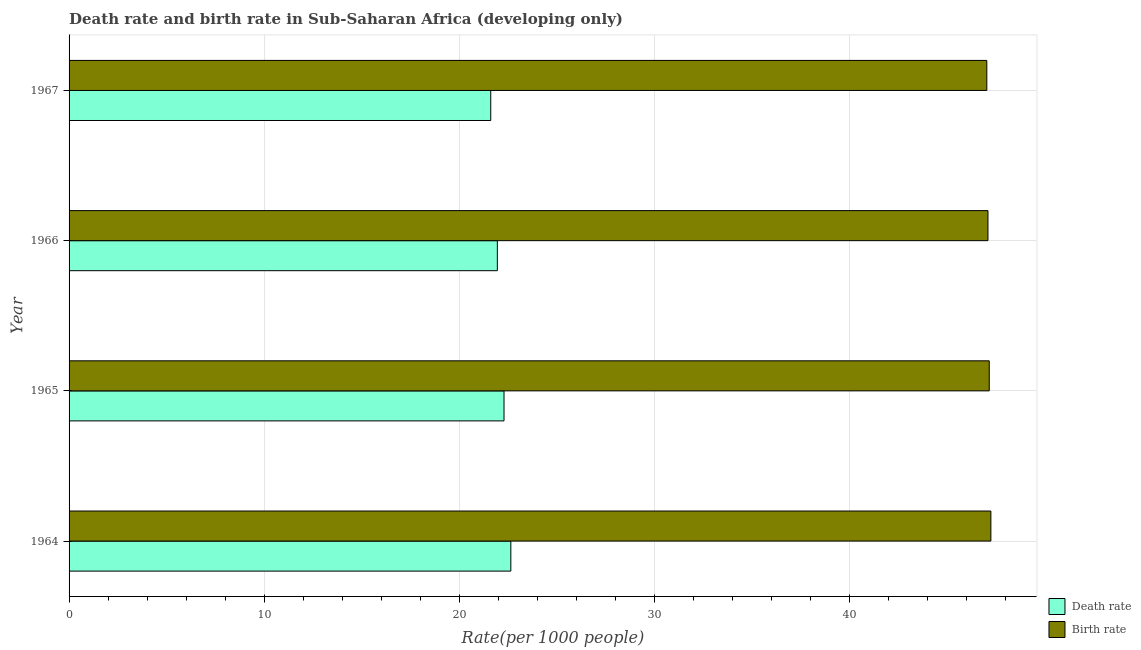How many different coloured bars are there?
Offer a terse response. 2. Are the number of bars on each tick of the Y-axis equal?
Your answer should be very brief. Yes. How many bars are there on the 2nd tick from the top?
Give a very brief answer. 2. What is the label of the 3rd group of bars from the top?
Ensure brevity in your answer.  1965. What is the death rate in 1967?
Your answer should be compact. 21.62. Across all years, what is the maximum death rate?
Ensure brevity in your answer.  22.65. Across all years, what is the minimum death rate?
Your answer should be very brief. 21.62. In which year was the death rate maximum?
Provide a short and direct response. 1964. In which year was the death rate minimum?
Make the answer very short. 1967. What is the total death rate in the graph?
Your response must be concise. 88.54. What is the difference between the birth rate in 1964 and that in 1966?
Your response must be concise. 0.15. What is the difference between the birth rate in 1966 and the death rate in 1967?
Offer a very short reply. 25.5. What is the average birth rate per year?
Your answer should be very brief. 47.16. In the year 1966, what is the difference between the death rate and birth rate?
Provide a short and direct response. -25.16. Is the difference between the birth rate in 1964 and 1965 greater than the difference between the death rate in 1964 and 1965?
Provide a short and direct response. No. What is the difference between the highest and the second highest death rate?
Make the answer very short. 0.35. What is the difference between the highest and the lowest death rate?
Ensure brevity in your answer.  1.03. In how many years, is the death rate greater than the average death rate taken over all years?
Provide a succinct answer. 2. Is the sum of the death rate in 1964 and 1966 greater than the maximum birth rate across all years?
Give a very brief answer. No. What does the 1st bar from the top in 1964 represents?
Your answer should be compact. Birth rate. What does the 2nd bar from the bottom in 1965 represents?
Offer a terse response. Birth rate. Are all the bars in the graph horizontal?
Give a very brief answer. Yes. What is the difference between two consecutive major ticks on the X-axis?
Offer a very short reply. 10. Does the graph contain grids?
Make the answer very short. Yes. Where does the legend appear in the graph?
Your response must be concise. Bottom right. How many legend labels are there?
Offer a very short reply. 2. What is the title of the graph?
Keep it short and to the point. Death rate and birth rate in Sub-Saharan Africa (developing only). Does "National Visitors" appear as one of the legend labels in the graph?
Give a very brief answer. No. What is the label or title of the X-axis?
Your answer should be very brief. Rate(per 1000 people). What is the Rate(per 1000 people) in Death rate in 1964?
Your answer should be very brief. 22.65. What is the Rate(per 1000 people) of Birth rate in 1964?
Offer a terse response. 47.27. What is the Rate(per 1000 people) of Death rate in 1965?
Your answer should be compact. 22.3. What is the Rate(per 1000 people) in Birth rate in 1965?
Provide a short and direct response. 47.18. What is the Rate(per 1000 people) of Death rate in 1966?
Your answer should be very brief. 21.96. What is the Rate(per 1000 people) in Birth rate in 1966?
Provide a succinct answer. 47.12. What is the Rate(per 1000 people) of Death rate in 1967?
Your response must be concise. 21.62. What is the Rate(per 1000 people) of Birth rate in 1967?
Provide a short and direct response. 47.06. Across all years, what is the maximum Rate(per 1000 people) of Death rate?
Provide a succinct answer. 22.65. Across all years, what is the maximum Rate(per 1000 people) in Birth rate?
Keep it short and to the point. 47.27. Across all years, what is the minimum Rate(per 1000 people) of Death rate?
Your answer should be very brief. 21.62. Across all years, what is the minimum Rate(per 1000 people) in Birth rate?
Give a very brief answer. 47.06. What is the total Rate(per 1000 people) in Death rate in the graph?
Your answer should be very brief. 88.54. What is the total Rate(per 1000 people) in Birth rate in the graph?
Keep it short and to the point. 188.63. What is the difference between the Rate(per 1000 people) of Death rate in 1964 and that in 1965?
Offer a very short reply. 0.35. What is the difference between the Rate(per 1000 people) in Birth rate in 1964 and that in 1965?
Your response must be concise. 0.08. What is the difference between the Rate(per 1000 people) in Death rate in 1964 and that in 1966?
Your response must be concise. 0.69. What is the difference between the Rate(per 1000 people) in Birth rate in 1964 and that in 1966?
Provide a succinct answer. 0.15. What is the difference between the Rate(per 1000 people) of Death rate in 1964 and that in 1967?
Keep it short and to the point. 1.03. What is the difference between the Rate(per 1000 people) in Birth rate in 1964 and that in 1967?
Provide a short and direct response. 0.21. What is the difference between the Rate(per 1000 people) in Death rate in 1965 and that in 1966?
Provide a short and direct response. 0.34. What is the difference between the Rate(per 1000 people) in Birth rate in 1965 and that in 1966?
Your answer should be compact. 0.07. What is the difference between the Rate(per 1000 people) in Death rate in 1965 and that in 1967?
Your answer should be very brief. 0.68. What is the difference between the Rate(per 1000 people) of Birth rate in 1965 and that in 1967?
Provide a short and direct response. 0.13. What is the difference between the Rate(per 1000 people) of Death rate in 1966 and that in 1967?
Ensure brevity in your answer.  0.34. What is the difference between the Rate(per 1000 people) of Death rate in 1964 and the Rate(per 1000 people) of Birth rate in 1965?
Your answer should be compact. -24.53. What is the difference between the Rate(per 1000 people) of Death rate in 1964 and the Rate(per 1000 people) of Birth rate in 1966?
Your response must be concise. -24.47. What is the difference between the Rate(per 1000 people) of Death rate in 1964 and the Rate(per 1000 people) of Birth rate in 1967?
Your response must be concise. -24.41. What is the difference between the Rate(per 1000 people) of Death rate in 1965 and the Rate(per 1000 people) of Birth rate in 1966?
Provide a succinct answer. -24.82. What is the difference between the Rate(per 1000 people) in Death rate in 1965 and the Rate(per 1000 people) in Birth rate in 1967?
Your answer should be compact. -24.76. What is the difference between the Rate(per 1000 people) in Death rate in 1966 and the Rate(per 1000 people) in Birth rate in 1967?
Keep it short and to the point. -25.1. What is the average Rate(per 1000 people) in Death rate per year?
Offer a very short reply. 22.13. What is the average Rate(per 1000 people) of Birth rate per year?
Ensure brevity in your answer.  47.16. In the year 1964, what is the difference between the Rate(per 1000 people) of Death rate and Rate(per 1000 people) of Birth rate?
Your response must be concise. -24.62. In the year 1965, what is the difference between the Rate(per 1000 people) in Death rate and Rate(per 1000 people) in Birth rate?
Your response must be concise. -24.88. In the year 1966, what is the difference between the Rate(per 1000 people) of Death rate and Rate(per 1000 people) of Birth rate?
Make the answer very short. -25.16. In the year 1967, what is the difference between the Rate(per 1000 people) in Death rate and Rate(per 1000 people) in Birth rate?
Keep it short and to the point. -25.44. What is the ratio of the Rate(per 1000 people) in Death rate in 1964 to that in 1965?
Your answer should be very brief. 1.02. What is the ratio of the Rate(per 1000 people) of Death rate in 1964 to that in 1966?
Your answer should be compact. 1.03. What is the ratio of the Rate(per 1000 people) in Death rate in 1964 to that in 1967?
Your response must be concise. 1.05. What is the ratio of the Rate(per 1000 people) in Birth rate in 1964 to that in 1967?
Offer a very short reply. 1. What is the ratio of the Rate(per 1000 people) in Death rate in 1965 to that in 1966?
Provide a succinct answer. 1.02. What is the ratio of the Rate(per 1000 people) of Birth rate in 1965 to that in 1966?
Your answer should be compact. 1. What is the ratio of the Rate(per 1000 people) in Death rate in 1965 to that in 1967?
Offer a terse response. 1.03. What is the ratio of the Rate(per 1000 people) of Death rate in 1966 to that in 1967?
Provide a short and direct response. 1.02. What is the ratio of the Rate(per 1000 people) in Birth rate in 1966 to that in 1967?
Offer a very short reply. 1. What is the difference between the highest and the second highest Rate(per 1000 people) in Death rate?
Your answer should be compact. 0.35. What is the difference between the highest and the second highest Rate(per 1000 people) in Birth rate?
Your answer should be compact. 0.08. What is the difference between the highest and the lowest Rate(per 1000 people) of Death rate?
Your answer should be very brief. 1.03. What is the difference between the highest and the lowest Rate(per 1000 people) of Birth rate?
Your response must be concise. 0.21. 